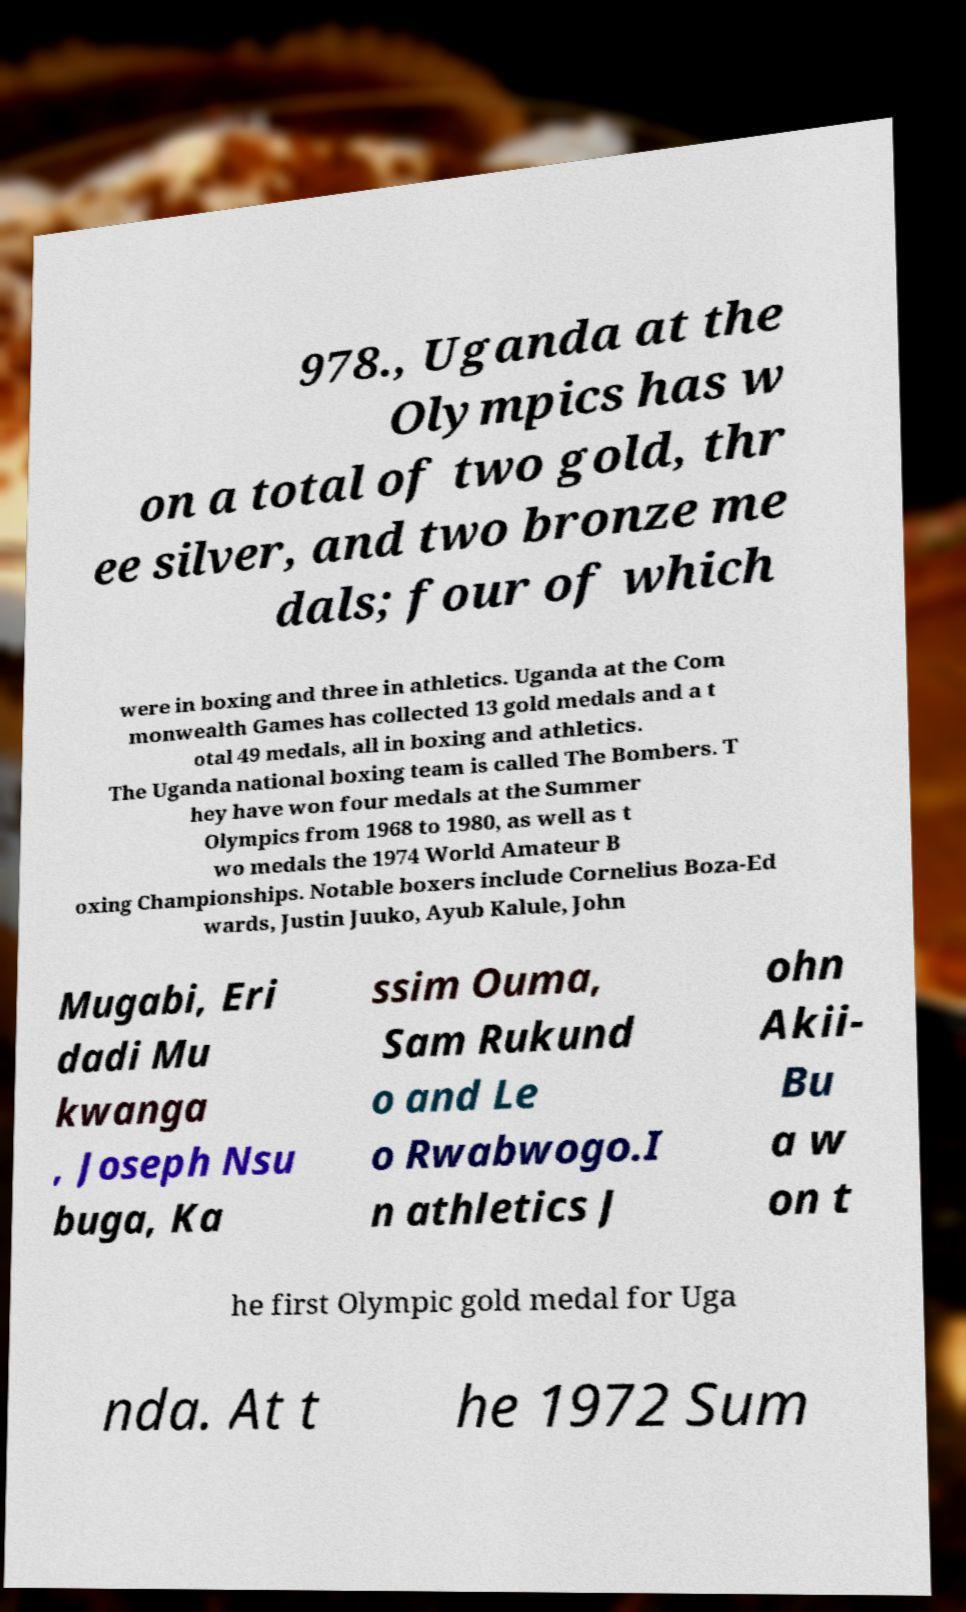Could you extract and type out the text from this image? 978., Uganda at the Olympics has w on a total of two gold, thr ee silver, and two bronze me dals; four of which were in boxing and three in athletics. Uganda at the Com monwealth Games has collected 13 gold medals and a t otal 49 medals, all in boxing and athletics. The Uganda national boxing team is called The Bombers. T hey have won four medals at the Summer Olympics from 1968 to 1980, as well as t wo medals the 1974 World Amateur B oxing Championships. Notable boxers include Cornelius Boza-Ed wards, Justin Juuko, Ayub Kalule, John Mugabi, Eri dadi Mu kwanga , Joseph Nsu buga, Ka ssim Ouma, Sam Rukund o and Le o Rwabwogo.I n athletics J ohn Akii- Bu a w on t he first Olympic gold medal for Uga nda. At t he 1972 Sum 